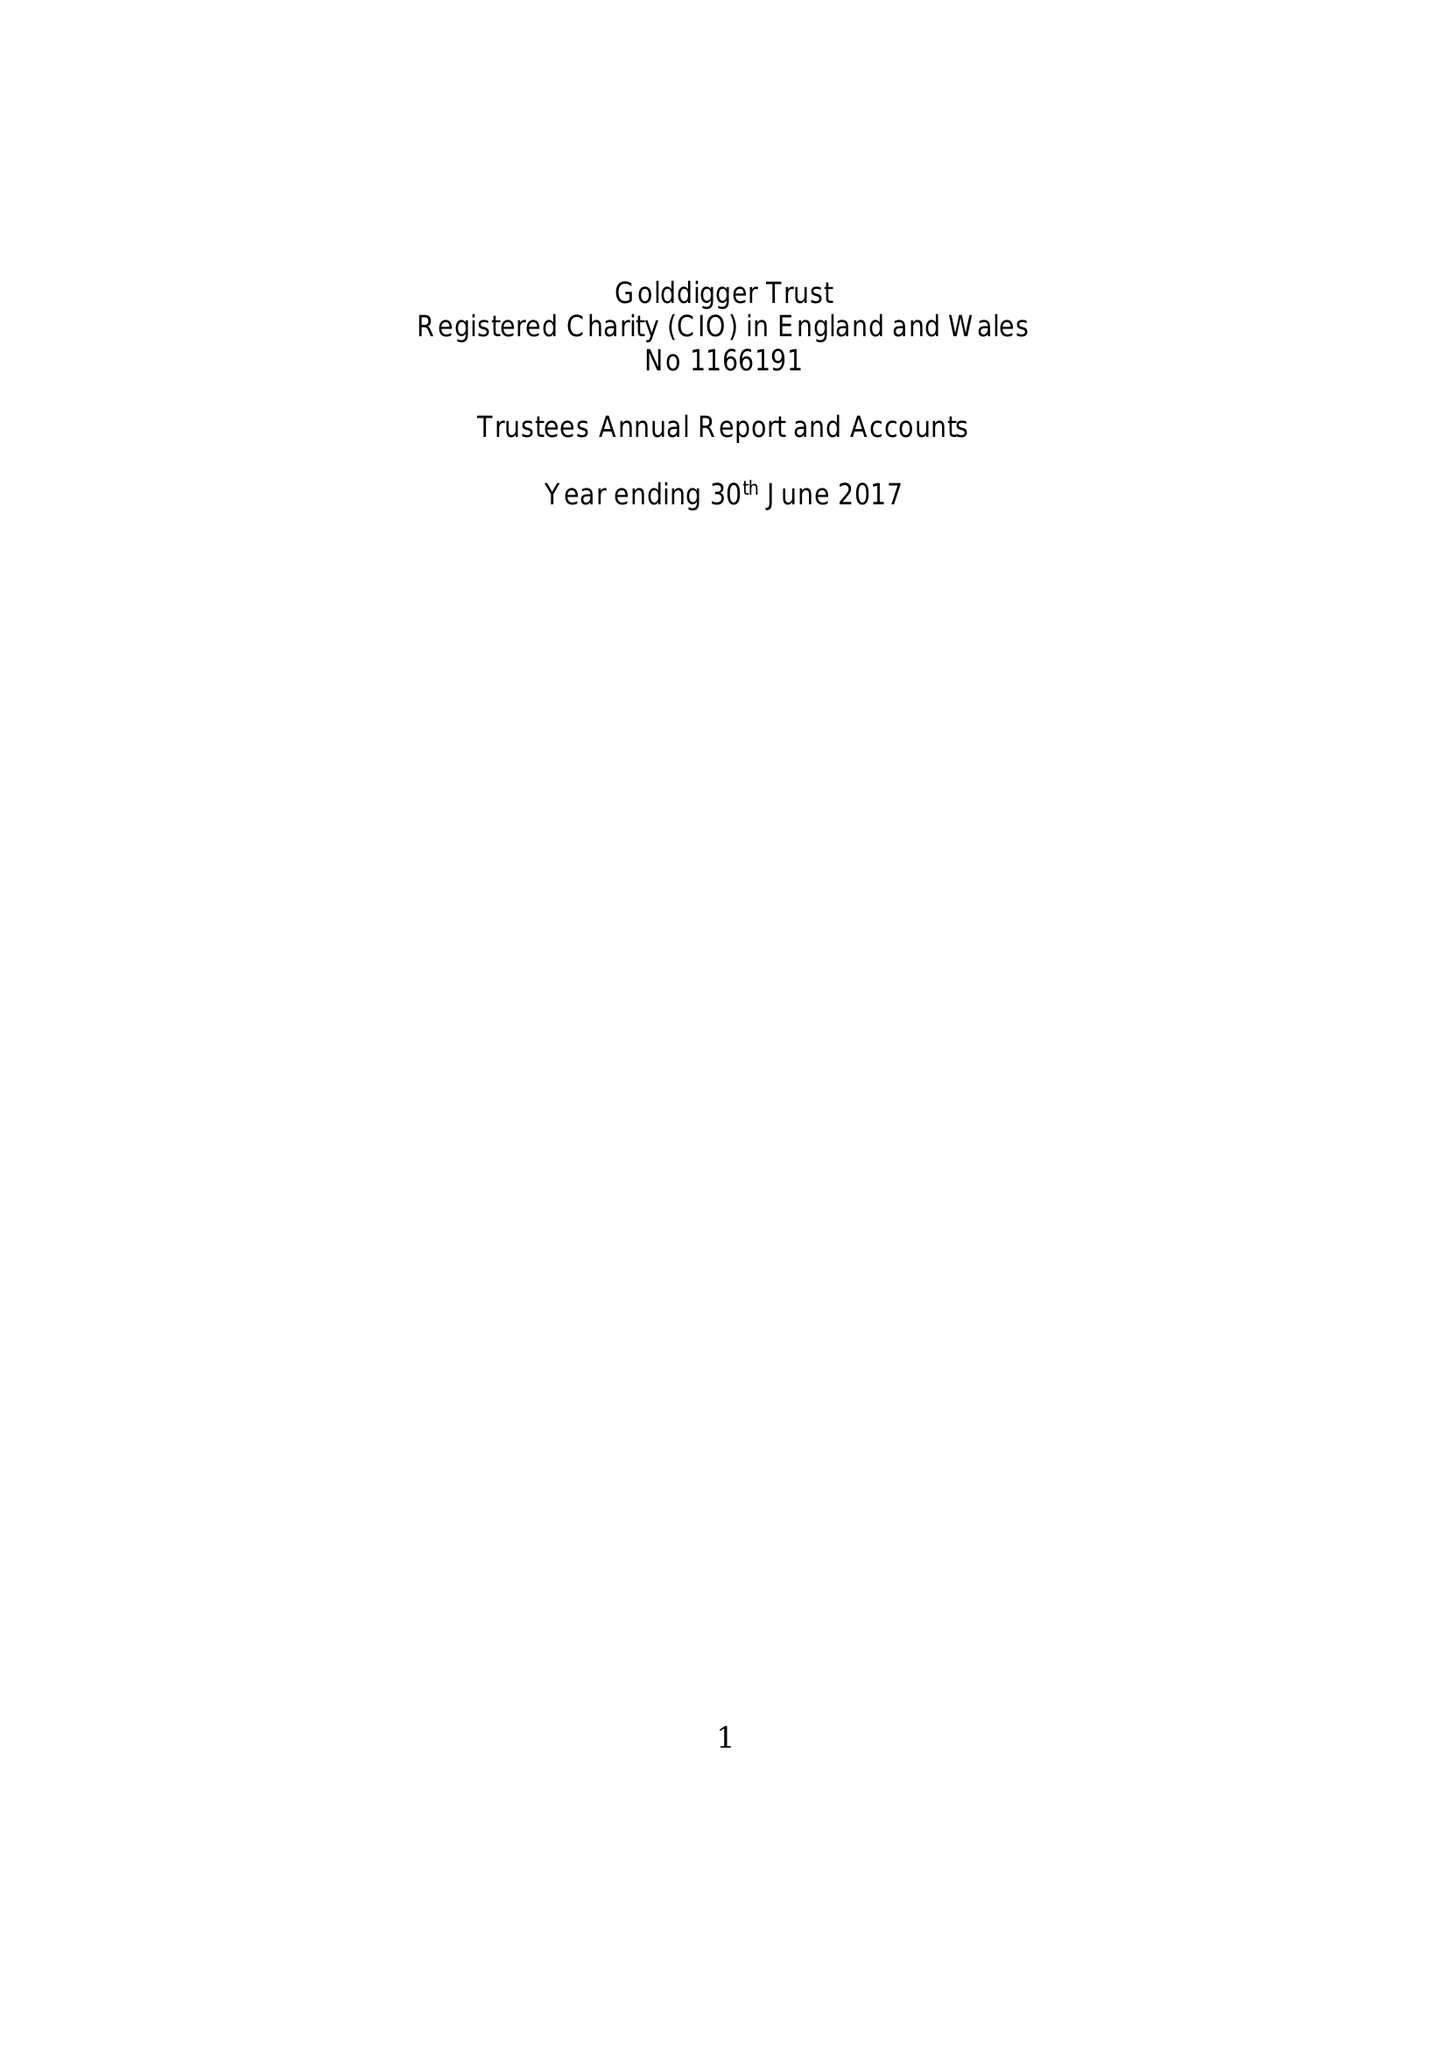What is the value for the report_date?
Answer the question using a single word or phrase. 2017-06-30 